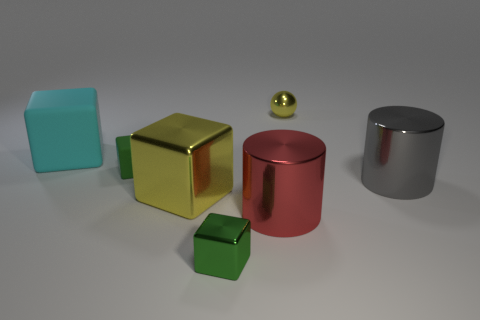Subtract all small green matte cubes. How many cubes are left? 3 Subtract all red balls. How many green blocks are left? 2 Add 2 green metallic blocks. How many objects exist? 9 Subtract all green cubes. How many cubes are left? 2 Subtract all cubes. How many objects are left? 3 Subtract all cyan blocks. Subtract all red cylinders. How many blocks are left? 3 Subtract all big green spheres. Subtract all cyan objects. How many objects are left? 6 Add 2 red cylinders. How many red cylinders are left? 3 Add 1 matte cubes. How many matte cubes exist? 3 Subtract 0 red blocks. How many objects are left? 7 